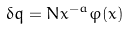Convert formula to latex. <formula><loc_0><loc_0><loc_500><loc_500>\delta q = N x ^ { - a } \varphi ( x )</formula> 